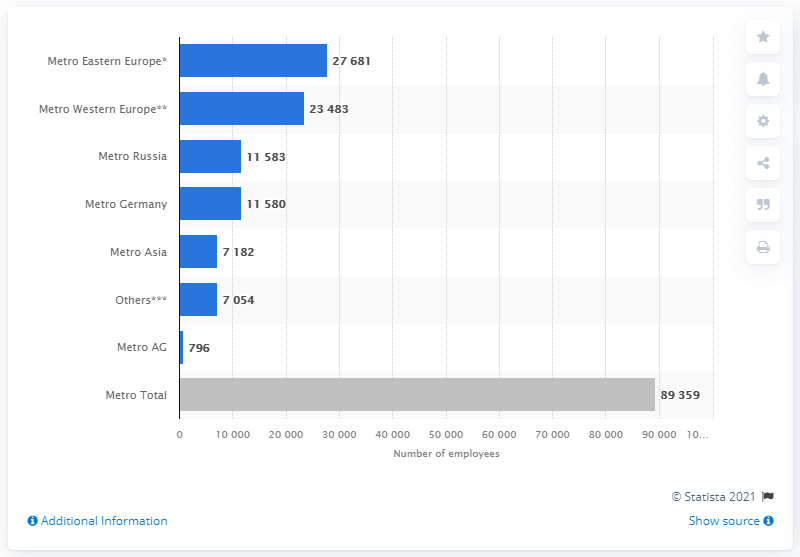Draw attention to some important aspects in this diagram. As of 2021, the total number of full-time equivalent employees at Metro AG was 796. 